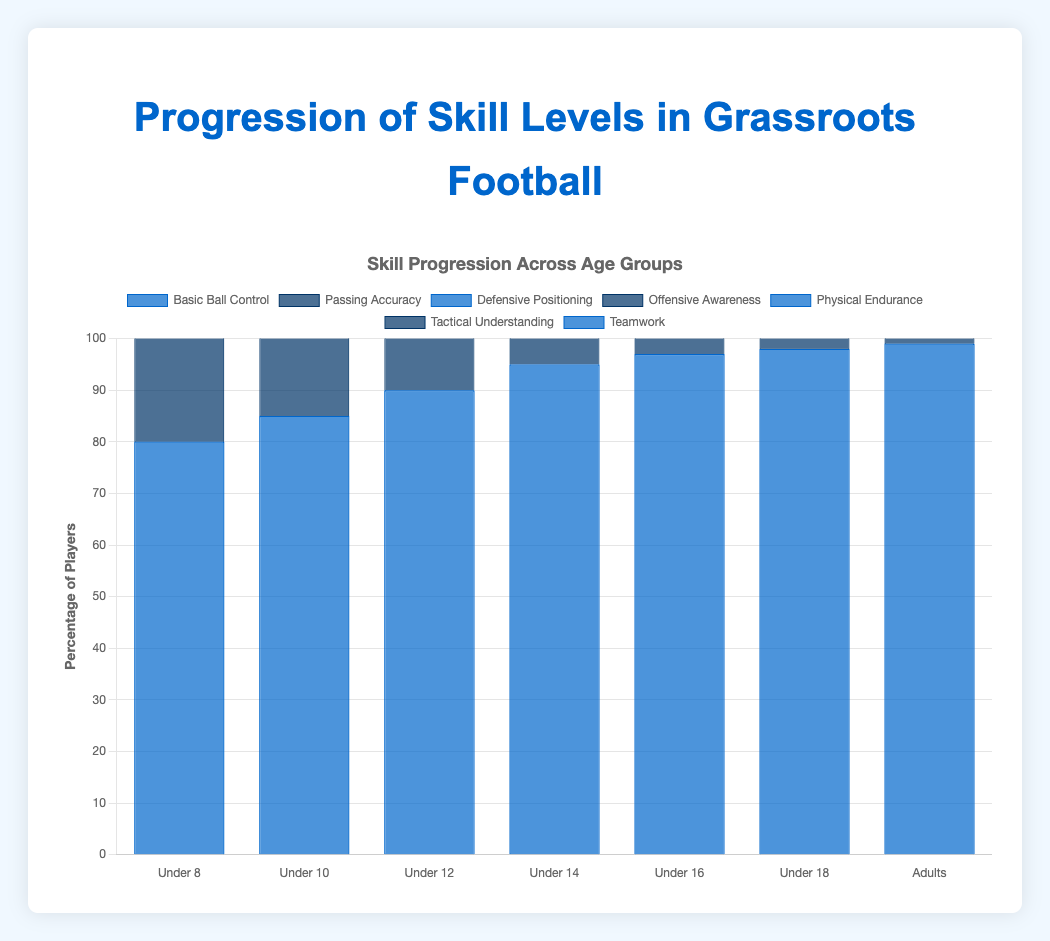What's the skill level with the highest percentage of players in the Under 12 age group? To find this, refer to the percentages for the Under 12 age group. The highest percentage is 90% for Basic Ball Control.
Answer: Basic Ball Control Which skill level shows the largest improvement in percentage from Under 8 to Adults? Calculate the difference in percentages from Under 8 to Adults for each skill level. Basic Ball Control: 99% - 80% = 19%, Passing Accuracy: 95% - 70% = 25%, Defensive Positioning: 90% - 60% = 30%, Offensive Awareness: 85% - 55% = 30%, Physical Endurance: 80% - 50% = 30%, Tactical Understanding: 75% - 45% = 30%, Teamwork: 97% - 85% = 12%. Several skill levels (Defensive Positioning, Offensive Awareness, Physical Endurance, and Tactical Understanding) all improved by 30%.
Answer: Defensive Positioning, Offensive Awareness, Physical Endurance, Tactical Understanding In the Under 16 age group, which skill levels have an equal percentage of players? Look at the percentages for the Under 16 age group and identify any that are the same. Passing Accuracy shows 88% and Defensive Positioning shows 80%. No clear match with equal percentages.
Answer: None What is the average percentage of players across all age groups for Teamwork? Sum the percentages for Teamwork across all age groups and divide by the number of age groups: (85 + 87 + 90 + 92 + 94 + 95 + 97) / 7 = 640 / 7 ≈ 91.4%.
Answer: 91.4% Which age group shows the greatest improvement in Passing Accuracy from the previous age group? Calculate the differences in Passing Accuracy between consecutive age groups: Under 10 - Under 8: 75% - 70% = 5%, Under 12 - Under 10: 80% - 75% = 5%, Under 14 - Under 12: 85% - 80% = 5%, Under 16 - Under 14: 88% - 85% = 3%, Under 18 - Under 16: 90% - 88% = 2%, Adults - Under 18: 95% - 90% = 5%. The differences are mostly 5%, so there’s no single greatest improvement.
Answer: None Which skill level reaches at least 80% for the first time in the Under 14 age group? Identify which skill levels have their percentages reaching 80% for the first time: Defensive Positioning reaches 80% in the Under 16 age group, so the skill level that reaches 80% first would be Passing Accuracy at Under 14 from 75% in Under 12 to 80% in Under 14.
Answer: Passing Accuracy What is the difference in percentage of players between Basic Ball Control and Physical Endurance for the Under 18 age group? Subtract the percentage of Physical Endurance from Basic Ball Control for the Under 18 age group: 98% - 75% = 23%.
Answer: 23% For which age groups is the percentage of players with Offensive Awareness less than 70%? Identify the age groups with Offensive Awareness percentage below 70%: Under 8: 55%, Under 10: 60%, Under 12: 65%, Under 14: 70% (exactly 70%, not less than).
Answer: Under 8, Under 10, Under 12 Which skill level has the lowest percentage of players in the Under 16 age group? Look at the percentages for the Under 16 age group and identify the lowest value. Tactical Understanding has the lowest at 65%.
Answer: Tactical Understanding 